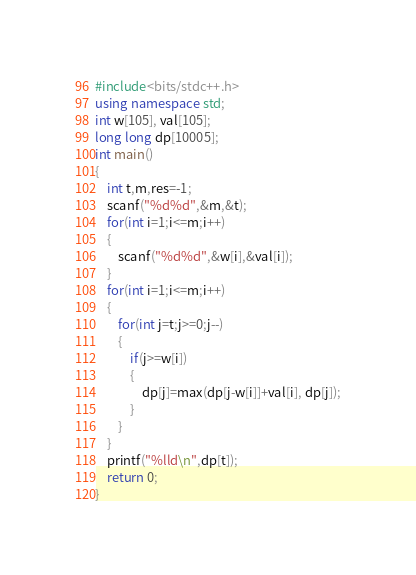Convert code to text. <code><loc_0><loc_0><loc_500><loc_500><_C++_>#include<bits/stdc++.h>
using namespace std;
int w[105], val[105];
long long dp[10005];
int main()
{
    int t,m,res=-1;    
    scanf("%d%d",&m,&t);
    for(int i=1;i<=m;i++)
    {
        scanf("%d%d",&w[i],&val[i]);
    }
    for(int i=1;i<=m;i++) 
    {
        for(int j=t;j>=0;j--) 
        {
            if(j>=w[i])
            {
                dp[j]=max(dp[j-w[i]]+val[i], dp[j]);
            }
        }
    }    
    printf("%lld\n",dp[t]);
    return 0;
}
</code> 